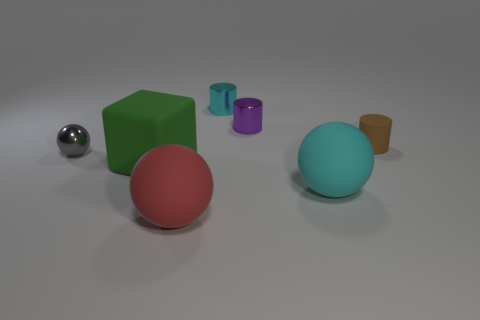Subtract all purple cylinders. Subtract all green balls. How many cylinders are left? 2 Add 2 cyan things. How many objects exist? 9 Subtract all spheres. How many objects are left? 4 Add 6 matte things. How many matte things exist? 10 Subtract 0 gray blocks. How many objects are left? 7 Subtract all purple cubes. Subtract all tiny purple cylinders. How many objects are left? 6 Add 4 small rubber objects. How many small rubber objects are left? 5 